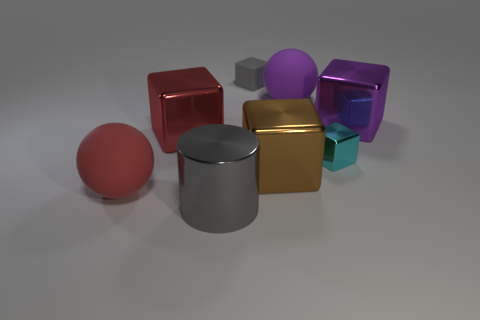There is a block that is behind the red metallic thing and on the right side of the big brown metal cube; what is its material?
Offer a terse response. Metal. There is another object that is the same color as the tiny rubber thing; what is its size?
Offer a very short reply. Large. Is there a small block that has the same color as the shiny cylinder?
Ensure brevity in your answer.  Yes. Do the tiny rubber cube and the metallic thing that is in front of the big brown cube have the same color?
Ensure brevity in your answer.  Yes. The purple rubber object that is the same shape as the large red matte thing is what size?
Your answer should be very brief. Large. Does the metal object in front of the big brown block have the same color as the small matte cube?
Keep it short and to the point. Yes. What is the shape of the purple object that is left of the large purple object that is in front of the big rubber sphere to the right of the large gray cylinder?
Your response must be concise. Sphere. How many balls are purple matte objects or big gray metal objects?
Your answer should be very brief. 1. Are there any cyan objects to the left of the gray object that is behind the red shiny thing?
Your response must be concise. No. Are there any other things that are made of the same material as the large purple ball?
Offer a terse response. Yes. 